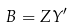Convert formula to latex. <formula><loc_0><loc_0><loc_500><loc_500>B = Z Y ^ { \prime }</formula> 